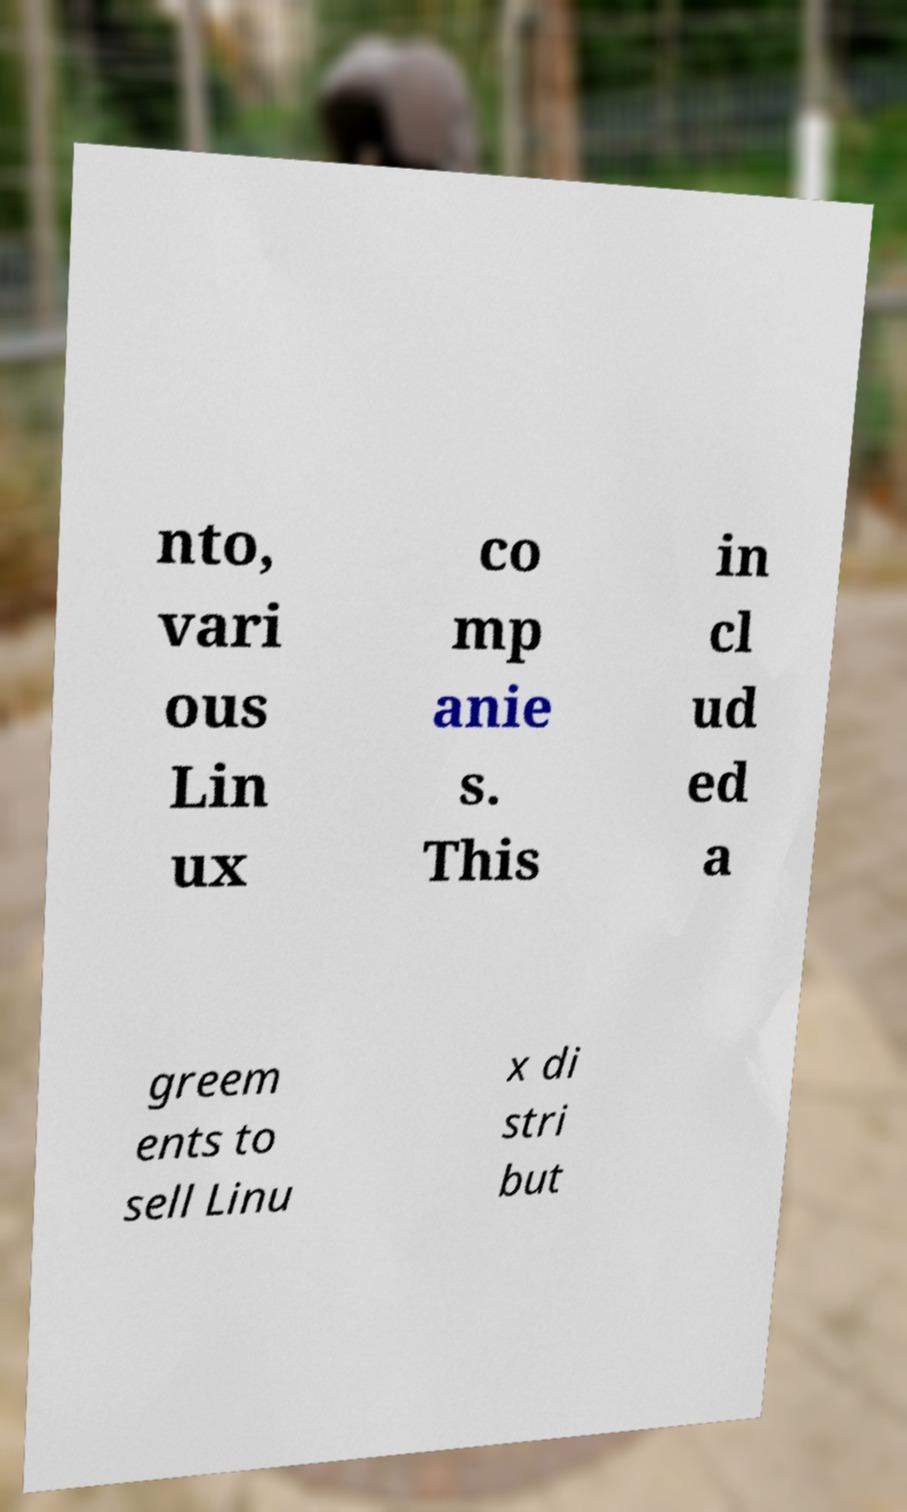For documentation purposes, I need the text within this image transcribed. Could you provide that? nto, vari ous Lin ux co mp anie s. This in cl ud ed a greem ents to sell Linu x di stri but 